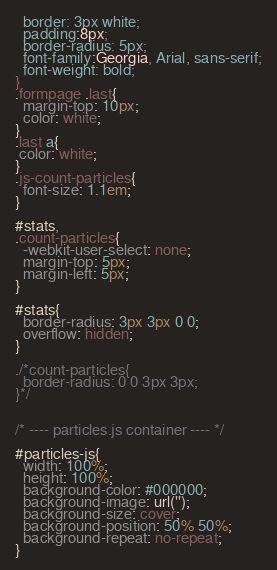<code> <loc_0><loc_0><loc_500><loc_500><_CSS_>  border: 3px white;
  padding:8px;
  border-radius: 5px;
  font-family:Georgia, Arial, sans-serif;
  font-weight: bold;
}
.formpage .last{
  margin-top: 10px;
  color: white;
}
.last a{
 color: white;
}
.js-count-particles{
  font-size: 1.1em;
}

#stats,
.count-particles{
  -webkit-user-select: none;
  margin-top: 5px;
  margin-left: 5px;
}

#stats{
  border-radius: 3px 3px 0 0;
  overflow: hidden;
}

./*count-particles{
  border-radius: 0 0 3px 3px;
}*/


/* ---- particles.js container ---- */

#particles-js{
  width: 100%;
  height: 100%;
  background-color: #000000;
  background-image: url('');
  background-size: cover;
  background-position: 50% 50%;
  background-repeat: no-repeat;
}
</code> 